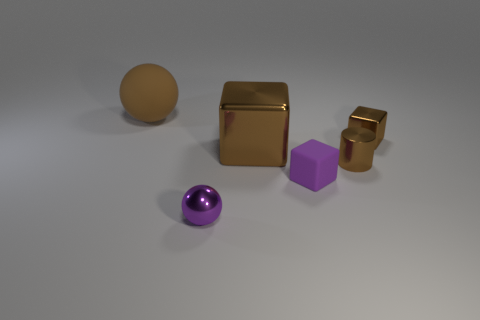Subtract all brown cubes. How many cubes are left? 1 Subtract all brown blocks. How many blocks are left? 1 Subtract all green cubes. Subtract all cyan cylinders. How many cubes are left? 3 Subtract all green cubes. How many brown balls are left? 1 Subtract all red rubber things. Subtract all rubber cubes. How many objects are left? 5 Add 4 big brown shiny cubes. How many big brown shiny cubes are left? 5 Add 4 tiny purple metal things. How many tiny purple metal things exist? 5 Add 3 tiny red metallic balls. How many objects exist? 9 Subtract 0 blue cubes. How many objects are left? 6 Subtract all cylinders. How many objects are left? 5 